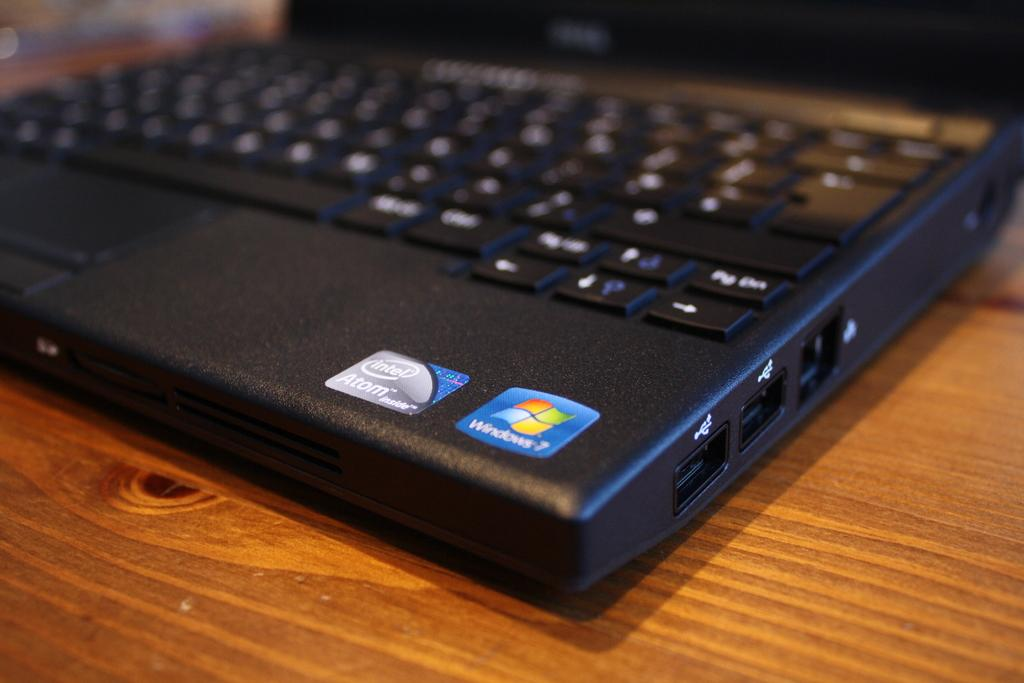<image>
Write a terse but informative summary of the picture. Black laptop keyboard with a sticker that says Windows 7. 